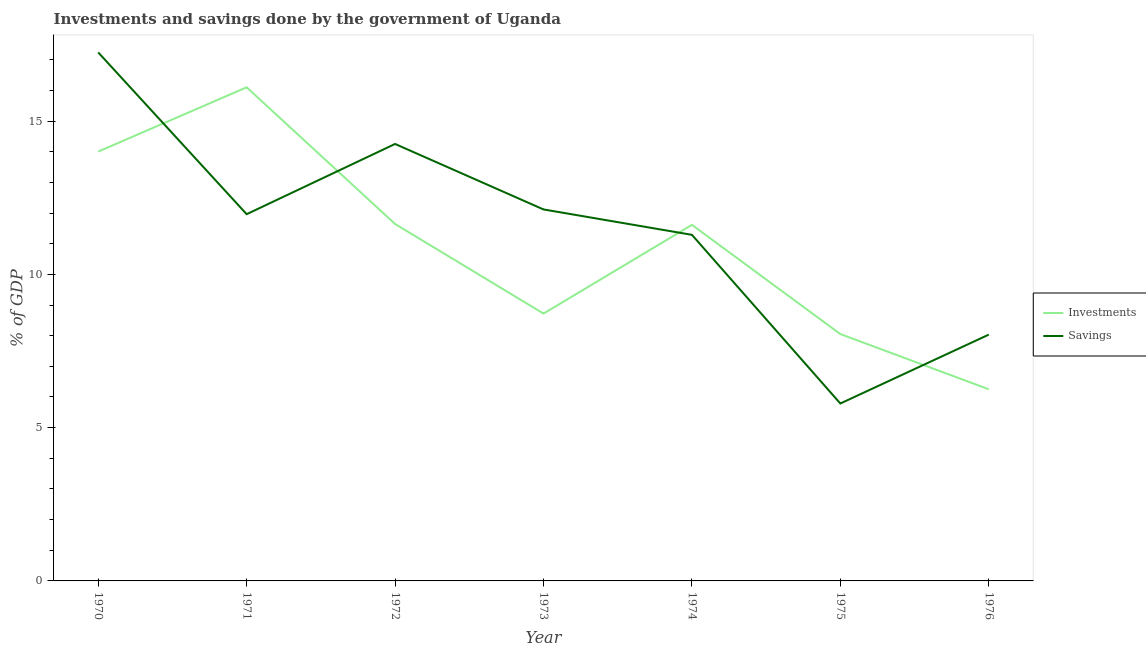How many different coloured lines are there?
Offer a terse response. 2. Is the number of lines equal to the number of legend labels?
Your answer should be very brief. Yes. What is the investments of government in 1971?
Provide a succinct answer. 16.1. Across all years, what is the maximum investments of government?
Ensure brevity in your answer.  16.1. Across all years, what is the minimum investments of government?
Give a very brief answer. 6.25. In which year was the investments of government maximum?
Offer a terse response. 1971. In which year was the investments of government minimum?
Keep it short and to the point. 1976. What is the total investments of government in the graph?
Give a very brief answer. 76.39. What is the difference between the investments of government in 1972 and that in 1973?
Provide a short and direct response. 2.92. What is the difference between the investments of government in 1975 and the savings of government in 1973?
Your response must be concise. -4.07. What is the average investments of government per year?
Provide a short and direct response. 10.91. In the year 1970, what is the difference between the investments of government and savings of government?
Keep it short and to the point. -3.23. In how many years, is the investments of government greater than 10 %?
Your answer should be very brief. 4. What is the ratio of the investments of government in 1972 to that in 1973?
Keep it short and to the point. 1.34. Is the savings of government in 1970 less than that in 1974?
Keep it short and to the point. No. What is the difference between the highest and the second highest investments of government?
Offer a terse response. 2.1. What is the difference between the highest and the lowest savings of government?
Your answer should be very brief. 11.45. In how many years, is the investments of government greater than the average investments of government taken over all years?
Offer a terse response. 4. Is the sum of the savings of government in 1971 and 1976 greater than the maximum investments of government across all years?
Offer a terse response. Yes. Does the investments of government monotonically increase over the years?
Your answer should be very brief. No. How many lines are there?
Provide a short and direct response. 2. How many years are there in the graph?
Offer a terse response. 7. What is the difference between two consecutive major ticks on the Y-axis?
Keep it short and to the point. 5. Are the values on the major ticks of Y-axis written in scientific E-notation?
Provide a short and direct response. No. How many legend labels are there?
Offer a very short reply. 2. What is the title of the graph?
Your answer should be very brief. Investments and savings done by the government of Uganda. Does "Net National savings" appear as one of the legend labels in the graph?
Provide a succinct answer. No. What is the label or title of the Y-axis?
Offer a terse response. % of GDP. What is the % of GDP in Investments in 1970?
Offer a terse response. 14. What is the % of GDP in Savings in 1970?
Ensure brevity in your answer.  17.24. What is the % of GDP of Investments in 1971?
Ensure brevity in your answer.  16.1. What is the % of GDP in Savings in 1971?
Your answer should be compact. 11.96. What is the % of GDP of Investments in 1972?
Your response must be concise. 11.64. What is the % of GDP of Savings in 1972?
Offer a very short reply. 14.25. What is the % of GDP of Investments in 1973?
Provide a short and direct response. 8.72. What is the % of GDP of Savings in 1973?
Offer a very short reply. 12.12. What is the % of GDP of Investments in 1974?
Offer a very short reply. 11.62. What is the % of GDP in Savings in 1974?
Give a very brief answer. 11.29. What is the % of GDP of Investments in 1975?
Offer a very short reply. 8.05. What is the % of GDP in Savings in 1975?
Offer a terse response. 5.79. What is the % of GDP in Investments in 1976?
Keep it short and to the point. 6.25. What is the % of GDP of Savings in 1976?
Your response must be concise. 8.03. Across all years, what is the maximum % of GDP in Investments?
Your answer should be very brief. 16.1. Across all years, what is the maximum % of GDP in Savings?
Your answer should be very brief. 17.24. Across all years, what is the minimum % of GDP in Investments?
Keep it short and to the point. 6.25. Across all years, what is the minimum % of GDP in Savings?
Keep it short and to the point. 5.79. What is the total % of GDP in Investments in the graph?
Offer a very short reply. 76.39. What is the total % of GDP in Savings in the graph?
Your answer should be very brief. 80.68. What is the difference between the % of GDP in Investments in 1970 and that in 1971?
Provide a short and direct response. -2.1. What is the difference between the % of GDP of Savings in 1970 and that in 1971?
Your answer should be very brief. 5.28. What is the difference between the % of GDP of Investments in 1970 and that in 1972?
Keep it short and to the point. 2.36. What is the difference between the % of GDP in Savings in 1970 and that in 1972?
Your answer should be compact. 2.99. What is the difference between the % of GDP of Investments in 1970 and that in 1973?
Provide a succinct answer. 5.28. What is the difference between the % of GDP in Savings in 1970 and that in 1973?
Keep it short and to the point. 5.12. What is the difference between the % of GDP of Investments in 1970 and that in 1974?
Give a very brief answer. 2.39. What is the difference between the % of GDP in Savings in 1970 and that in 1974?
Your response must be concise. 5.95. What is the difference between the % of GDP in Investments in 1970 and that in 1975?
Your answer should be compact. 5.95. What is the difference between the % of GDP in Savings in 1970 and that in 1975?
Provide a succinct answer. 11.45. What is the difference between the % of GDP of Investments in 1970 and that in 1976?
Your response must be concise. 7.75. What is the difference between the % of GDP in Savings in 1970 and that in 1976?
Provide a short and direct response. 9.21. What is the difference between the % of GDP in Investments in 1971 and that in 1972?
Give a very brief answer. 4.46. What is the difference between the % of GDP in Savings in 1971 and that in 1972?
Offer a very short reply. -2.29. What is the difference between the % of GDP in Investments in 1971 and that in 1973?
Your response must be concise. 7.38. What is the difference between the % of GDP in Savings in 1971 and that in 1973?
Offer a very short reply. -0.15. What is the difference between the % of GDP of Investments in 1971 and that in 1974?
Make the answer very short. 4.49. What is the difference between the % of GDP of Savings in 1971 and that in 1974?
Your answer should be compact. 0.67. What is the difference between the % of GDP in Investments in 1971 and that in 1975?
Offer a very short reply. 8.05. What is the difference between the % of GDP of Savings in 1971 and that in 1975?
Ensure brevity in your answer.  6.18. What is the difference between the % of GDP in Investments in 1971 and that in 1976?
Your response must be concise. 9.85. What is the difference between the % of GDP in Savings in 1971 and that in 1976?
Your response must be concise. 3.93. What is the difference between the % of GDP in Investments in 1972 and that in 1973?
Provide a short and direct response. 2.92. What is the difference between the % of GDP of Savings in 1972 and that in 1973?
Your answer should be very brief. 2.14. What is the difference between the % of GDP in Investments in 1972 and that in 1974?
Your response must be concise. 0.03. What is the difference between the % of GDP of Savings in 1972 and that in 1974?
Give a very brief answer. 2.96. What is the difference between the % of GDP of Investments in 1972 and that in 1975?
Provide a short and direct response. 3.59. What is the difference between the % of GDP in Savings in 1972 and that in 1975?
Your response must be concise. 8.47. What is the difference between the % of GDP in Investments in 1972 and that in 1976?
Make the answer very short. 5.39. What is the difference between the % of GDP in Savings in 1972 and that in 1976?
Offer a very short reply. 6.22. What is the difference between the % of GDP of Investments in 1973 and that in 1974?
Give a very brief answer. -2.9. What is the difference between the % of GDP of Savings in 1973 and that in 1974?
Provide a short and direct response. 0.83. What is the difference between the % of GDP in Investments in 1973 and that in 1975?
Provide a succinct answer. 0.67. What is the difference between the % of GDP of Savings in 1973 and that in 1975?
Offer a very short reply. 6.33. What is the difference between the % of GDP in Investments in 1973 and that in 1976?
Provide a succinct answer. 2.47. What is the difference between the % of GDP in Savings in 1973 and that in 1976?
Offer a very short reply. 4.08. What is the difference between the % of GDP of Investments in 1974 and that in 1975?
Give a very brief answer. 3.56. What is the difference between the % of GDP of Savings in 1974 and that in 1975?
Your answer should be very brief. 5.5. What is the difference between the % of GDP of Investments in 1974 and that in 1976?
Make the answer very short. 5.36. What is the difference between the % of GDP of Savings in 1974 and that in 1976?
Your answer should be very brief. 3.26. What is the difference between the % of GDP in Investments in 1975 and that in 1976?
Make the answer very short. 1.8. What is the difference between the % of GDP in Savings in 1975 and that in 1976?
Your answer should be compact. -2.25. What is the difference between the % of GDP in Investments in 1970 and the % of GDP in Savings in 1971?
Offer a very short reply. 2.04. What is the difference between the % of GDP in Investments in 1970 and the % of GDP in Savings in 1972?
Provide a succinct answer. -0.25. What is the difference between the % of GDP of Investments in 1970 and the % of GDP of Savings in 1973?
Offer a very short reply. 1.89. What is the difference between the % of GDP in Investments in 1970 and the % of GDP in Savings in 1974?
Offer a very short reply. 2.72. What is the difference between the % of GDP in Investments in 1970 and the % of GDP in Savings in 1975?
Give a very brief answer. 8.22. What is the difference between the % of GDP of Investments in 1970 and the % of GDP of Savings in 1976?
Offer a terse response. 5.97. What is the difference between the % of GDP in Investments in 1971 and the % of GDP in Savings in 1972?
Provide a short and direct response. 1.85. What is the difference between the % of GDP of Investments in 1971 and the % of GDP of Savings in 1973?
Make the answer very short. 3.98. What is the difference between the % of GDP in Investments in 1971 and the % of GDP in Savings in 1974?
Provide a short and direct response. 4.81. What is the difference between the % of GDP of Investments in 1971 and the % of GDP of Savings in 1975?
Provide a short and direct response. 10.31. What is the difference between the % of GDP in Investments in 1971 and the % of GDP in Savings in 1976?
Make the answer very short. 8.07. What is the difference between the % of GDP in Investments in 1972 and the % of GDP in Savings in 1973?
Offer a very short reply. -0.47. What is the difference between the % of GDP of Investments in 1972 and the % of GDP of Savings in 1974?
Offer a very short reply. 0.35. What is the difference between the % of GDP in Investments in 1972 and the % of GDP in Savings in 1975?
Offer a terse response. 5.86. What is the difference between the % of GDP in Investments in 1972 and the % of GDP in Savings in 1976?
Provide a short and direct response. 3.61. What is the difference between the % of GDP in Investments in 1973 and the % of GDP in Savings in 1974?
Keep it short and to the point. -2.57. What is the difference between the % of GDP in Investments in 1973 and the % of GDP in Savings in 1975?
Your response must be concise. 2.93. What is the difference between the % of GDP of Investments in 1973 and the % of GDP of Savings in 1976?
Your answer should be very brief. 0.69. What is the difference between the % of GDP of Investments in 1974 and the % of GDP of Savings in 1975?
Your answer should be very brief. 5.83. What is the difference between the % of GDP of Investments in 1974 and the % of GDP of Savings in 1976?
Offer a terse response. 3.58. What is the difference between the % of GDP of Investments in 1975 and the % of GDP of Savings in 1976?
Ensure brevity in your answer.  0.02. What is the average % of GDP of Investments per year?
Give a very brief answer. 10.91. What is the average % of GDP of Savings per year?
Provide a succinct answer. 11.53. In the year 1970, what is the difference between the % of GDP in Investments and % of GDP in Savings?
Make the answer very short. -3.23. In the year 1971, what is the difference between the % of GDP of Investments and % of GDP of Savings?
Keep it short and to the point. 4.14. In the year 1972, what is the difference between the % of GDP in Investments and % of GDP in Savings?
Keep it short and to the point. -2.61. In the year 1973, what is the difference between the % of GDP in Investments and % of GDP in Savings?
Your answer should be compact. -3.4. In the year 1974, what is the difference between the % of GDP of Investments and % of GDP of Savings?
Ensure brevity in your answer.  0.33. In the year 1975, what is the difference between the % of GDP of Investments and % of GDP of Savings?
Provide a short and direct response. 2.27. In the year 1976, what is the difference between the % of GDP in Investments and % of GDP in Savings?
Give a very brief answer. -1.78. What is the ratio of the % of GDP of Investments in 1970 to that in 1971?
Provide a short and direct response. 0.87. What is the ratio of the % of GDP in Savings in 1970 to that in 1971?
Give a very brief answer. 1.44. What is the ratio of the % of GDP of Investments in 1970 to that in 1972?
Ensure brevity in your answer.  1.2. What is the ratio of the % of GDP of Savings in 1970 to that in 1972?
Your response must be concise. 1.21. What is the ratio of the % of GDP of Investments in 1970 to that in 1973?
Make the answer very short. 1.61. What is the ratio of the % of GDP in Savings in 1970 to that in 1973?
Offer a terse response. 1.42. What is the ratio of the % of GDP of Investments in 1970 to that in 1974?
Ensure brevity in your answer.  1.21. What is the ratio of the % of GDP of Savings in 1970 to that in 1974?
Your response must be concise. 1.53. What is the ratio of the % of GDP of Investments in 1970 to that in 1975?
Provide a short and direct response. 1.74. What is the ratio of the % of GDP of Savings in 1970 to that in 1975?
Make the answer very short. 2.98. What is the ratio of the % of GDP of Investments in 1970 to that in 1976?
Give a very brief answer. 2.24. What is the ratio of the % of GDP in Savings in 1970 to that in 1976?
Your answer should be very brief. 2.15. What is the ratio of the % of GDP of Investments in 1971 to that in 1972?
Keep it short and to the point. 1.38. What is the ratio of the % of GDP of Savings in 1971 to that in 1972?
Give a very brief answer. 0.84. What is the ratio of the % of GDP in Investments in 1971 to that in 1973?
Your answer should be very brief. 1.85. What is the ratio of the % of GDP of Savings in 1971 to that in 1973?
Give a very brief answer. 0.99. What is the ratio of the % of GDP of Investments in 1971 to that in 1974?
Your response must be concise. 1.39. What is the ratio of the % of GDP of Savings in 1971 to that in 1974?
Provide a succinct answer. 1.06. What is the ratio of the % of GDP in Investments in 1971 to that in 1975?
Keep it short and to the point. 2. What is the ratio of the % of GDP of Savings in 1971 to that in 1975?
Provide a succinct answer. 2.07. What is the ratio of the % of GDP in Investments in 1971 to that in 1976?
Your answer should be very brief. 2.58. What is the ratio of the % of GDP of Savings in 1971 to that in 1976?
Give a very brief answer. 1.49. What is the ratio of the % of GDP in Investments in 1972 to that in 1973?
Keep it short and to the point. 1.34. What is the ratio of the % of GDP of Savings in 1972 to that in 1973?
Provide a succinct answer. 1.18. What is the ratio of the % of GDP in Investments in 1972 to that in 1974?
Offer a very short reply. 1. What is the ratio of the % of GDP in Savings in 1972 to that in 1974?
Make the answer very short. 1.26. What is the ratio of the % of GDP in Investments in 1972 to that in 1975?
Provide a short and direct response. 1.45. What is the ratio of the % of GDP of Savings in 1972 to that in 1975?
Your response must be concise. 2.46. What is the ratio of the % of GDP of Investments in 1972 to that in 1976?
Keep it short and to the point. 1.86. What is the ratio of the % of GDP in Savings in 1972 to that in 1976?
Your response must be concise. 1.77. What is the ratio of the % of GDP in Investments in 1973 to that in 1974?
Your answer should be compact. 0.75. What is the ratio of the % of GDP of Savings in 1973 to that in 1974?
Make the answer very short. 1.07. What is the ratio of the % of GDP in Investments in 1973 to that in 1975?
Offer a very short reply. 1.08. What is the ratio of the % of GDP of Savings in 1973 to that in 1975?
Your response must be concise. 2.09. What is the ratio of the % of GDP in Investments in 1973 to that in 1976?
Provide a short and direct response. 1.39. What is the ratio of the % of GDP in Savings in 1973 to that in 1976?
Provide a short and direct response. 1.51. What is the ratio of the % of GDP of Investments in 1974 to that in 1975?
Ensure brevity in your answer.  1.44. What is the ratio of the % of GDP in Savings in 1974 to that in 1975?
Provide a short and direct response. 1.95. What is the ratio of the % of GDP in Investments in 1974 to that in 1976?
Provide a short and direct response. 1.86. What is the ratio of the % of GDP in Savings in 1974 to that in 1976?
Offer a terse response. 1.41. What is the ratio of the % of GDP in Investments in 1975 to that in 1976?
Ensure brevity in your answer.  1.29. What is the ratio of the % of GDP of Savings in 1975 to that in 1976?
Offer a terse response. 0.72. What is the difference between the highest and the second highest % of GDP of Investments?
Give a very brief answer. 2.1. What is the difference between the highest and the second highest % of GDP in Savings?
Ensure brevity in your answer.  2.99. What is the difference between the highest and the lowest % of GDP in Investments?
Your answer should be compact. 9.85. What is the difference between the highest and the lowest % of GDP of Savings?
Your answer should be very brief. 11.45. 